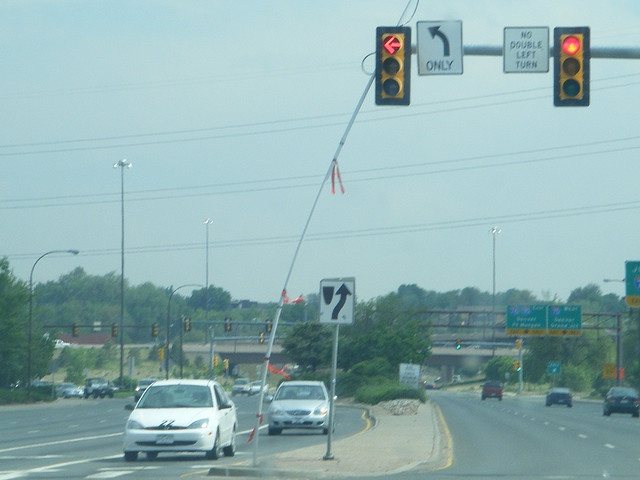Describe the objects in this image and their specific colors. I can see car in lightblue, white, teal, darkgray, and blue tones, traffic light in lightblue, blue, gray, and tan tones, car in lightblue, teal, and blue tones, traffic light in lightblue, blue, gray, tan, and darkblue tones, and car in lightblue, blue, teal, and darkblue tones in this image. 